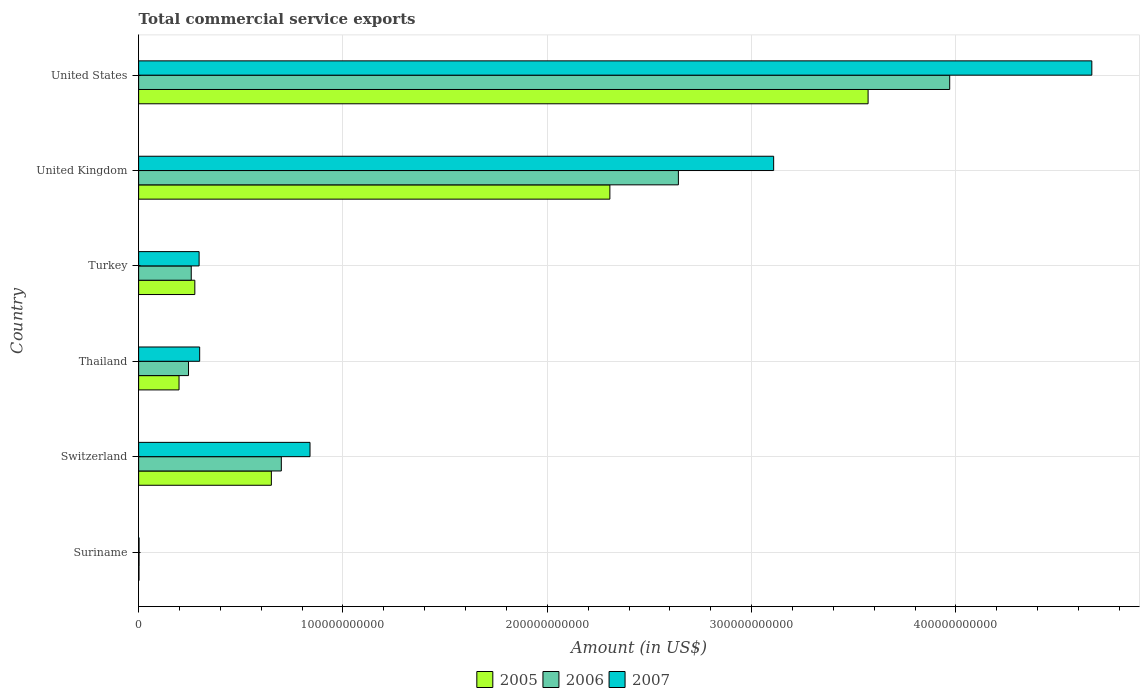How many groups of bars are there?
Keep it short and to the point. 6. Are the number of bars per tick equal to the number of legend labels?
Your answer should be compact. Yes. How many bars are there on the 1st tick from the top?
Give a very brief answer. 3. How many bars are there on the 5th tick from the bottom?
Ensure brevity in your answer.  3. What is the total commercial service exports in 2005 in United States?
Your answer should be compact. 3.57e+11. Across all countries, what is the maximum total commercial service exports in 2005?
Your answer should be very brief. 3.57e+11. Across all countries, what is the minimum total commercial service exports in 2005?
Give a very brief answer. 1.83e+08. In which country was the total commercial service exports in 2007 minimum?
Offer a terse response. Suriname. What is the total total commercial service exports in 2006 in the graph?
Make the answer very short. 7.81e+11. What is the difference between the total commercial service exports in 2006 in Suriname and that in Turkey?
Offer a very short reply. -2.55e+1. What is the difference between the total commercial service exports in 2005 in United Kingdom and the total commercial service exports in 2006 in United States?
Provide a short and direct response. -1.66e+11. What is the average total commercial service exports in 2005 per country?
Provide a succinct answer. 1.17e+11. What is the difference between the total commercial service exports in 2007 and total commercial service exports in 2005 in United Kingdom?
Keep it short and to the point. 8.02e+1. In how many countries, is the total commercial service exports in 2005 greater than 320000000000 US$?
Offer a very short reply. 1. What is the ratio of the total commercial service exports in 2006 in Switzerland to that in United Kingdom?
Your answer should be compact. 0.26. Is the total commercial service exports in 2007 in Switzerland less than that in United Kingdom?
Provide a succinct answer. Yes. What is the difference between the highest and the second highest total commercial service exports in 2007?
Keep it short and to the point. 1.56e+11. What is the difference between the highest and the lowest total commercial service exports in 2005?
Offer a very short reply. 3.57e+11. In how many countries, is the total commercial service exports in 2006 greater than the average total commercial service exports in 2006 taken over all countries?
Ensure brevity in your answer.  2. Is the sum of the total commercial service exports in 2007 in Suriname and United Kingdom greater than the maximum total commercial service exports in 2005 across all countries?
Your answer should be very brief. No. What does the 3rd bar from the bottom in United States represents?
Your answer should be compact. 2007. Is it the case that in every country, the sum of the total commercial service exports in 2007 and total commercial service exports in 2006 is greater than the total commercial service exports in 2005?
Offer a very short reply. Yes. How many bars are there?
Your answer should be compact. 18. Are all the bars in the graph horizontal?
Your answer should be very brief. Yes. What is the difference between two consecutive major ticks on the X-axis?
Offer a very short reply. 1.00e+11. Are the values on the major ticks of X-axis written in scientific E-notation?
Offer a very short reply. No. Does the graph contain any zero values?
Provide a short and direct response. No. Does the graph contain grids?
Provide a succinct answer. Yes. Where does the legend appear in the graph?
Provide a succinct answer. Bottom center. How many legend labels are there?
Provide a succinct answer. 3. How are the legend labels stacked?
Your response must be concise. Horizontal. What is the title of the graph?
Ensure brevity in your answer.  Total commercial service exports. What is the label or title of the X-axis?
Ensure brevity in your answer.  Amount (in US$). What is the label or title of the Y-axis?
Ensure brevity in your answer.  Country. What is the Amount (in US$) of 2005 in Suriname?
Provide a succinct answer. 1.83e+08. What is the Amount (in US$) of 2006 in Suriname?
Give a very brief answer. 2.14e+08. What is the Amount (in US$) of 2007 in Suriname?
Give a very brief answer. 2.19e+08. What is the Amount (in US$) of 2005 in Switzerland?
Your response must be concise. 6.50e+1. What is the Amount (in US$) of 2006 in Switzerland?
Your response must be concise. 6.98e+1. What is the Amount (in US$) of 2007 in Switzerland?
Give a very brief answer. 8.39e+1. What is the Amount (in US$) of 2005 in Thailand?
Give a very brief answer. 1.98e+1. What is the Amount (in US$) of 2006 in Thailand?
Make the answer very short. 2.44e+1. What is the Amount (in US$) in 2007 in Thailand?
Your response must be concise. 2.99e+1. What is the Amount (in US$) in 2005 in Turkey?
Keep it short and to the point. 2.75e+1. What is the Amount (in US$) of 2006 in Turkey?
Ensure brevity in your answer.  2.58e+1. What is the Amount (in US$) in 2007 in Turkey?
Provide a succinct answer. 2.96e+1. What is the Amount (in US$) in 2005 in United Kingdom?
Your response must be concise. 2.31e+11. What is the Amount (in US$) of 2006 in United Kingdom?
Provide a succinct answer. 2.64e+11. What is the Amount (in US$) of 2007 in United Kingdom?
Your answer should be very brief. 3.11e+11. What is the Amount (in US$) in 2005 in United States?
Offer a very short reply. 3.57e+11. What is the Amount (in US$) of 2006 in United States?
Provide a short and direct response. 3.97e+11. What is the Amount (in US$) of 2007 in United States?
Provide a succinct answer. 4.67e+11. Across all countries, what is the maximum Amount (in US$) of 2005?
Your answer should be very brief. 3.57e+11. Across all countries, what is the maximum Amount (in US$) in 2006?
Provide a succinct answer. 3.97e+11. Across all countries, what is the maximum Amount (in US$) of 2007?
Give a very brief answer. 4.67e+11. Across all countries, what is the minimum Amount (in US$) of 2005?
Keep it short and to the point. 1.83e+08. Across all countries, what is the minimum Amount (in US$) of 2006?
Your answer should be very brief. 2.14e+08. Across all countries, what is the minimum Amount (in US$) of 2007?
Your answer should be compact. 2.19e+08. What is the total Amount (in US$) in 2005 in the graph?
Your answer should be very brief. 7.00e+11. What is the total Amount (in US$) in 2006 in the graph?
Ensure brevity in your answer.  7.81e+11. What is the total Amount (in US$) in 2007 in the graph?
Offer a terse response. 9.21e+11. What is the difference between the Amount (in US$) of 2005 in Suriname and that in Switzerland?
Your answer should be very brief. -6.48e+1. What is the difference between the Amount (in US$) in 2006 in Suriname and that in Switzerland?
Make the answer very short. -6.96e+1. What is the difference between the Amount (in US$) in 2007 in Suriname and that in Switzerland?
Keep it short and to the point. -8.37e+1. What is the difference between the Amount (in US$) of 2005 in Suriname and that in Thailand?
Your answer should be compact. -1.96e+1. What is the difference between the Amount (in US$) in 2006 in Suriname and that in Thailand?
Your response must be concise. -2.42e+1. What is the difference between the Amount (in US$) in 2007 in Suriname and that in Thailand?
Keep it short and to the point. -2.97e+1. What is the difference between the Amount (in US$) in 2005 in Suriname and that in Turkey?
Offer a terse response. -2.73e+1. What is the difference between the Amount (in US$) of 2006 in Suriname and that in Turkey?
Offer a very short reply. -2.55e+1. What is the difference between the Amount (in US$) in 2007 in Suriname and that in Turkey?
Provide a short and direct response. -2.94e+1. What is the difference between the Amount (in US$) of 2005 in Suriname and that in United Kingdom?
Your response must be concise. -2.30e+11. What is the difference between the Amount (in US$) of 2006 in Suriname and that in United Kingdom?
Offer a terse response. -2.64e+11. What is the difference between the Amount (in US$) of 2007 in Suriname and that in United Kingdom?
Offer a terse response. -3.11e+11. What is the difference between the Amount (in US$) in 2005 in Suriname and that in United States?
Provide a short and direct response. -3.57e+11. What is the difference between the Amount (in US$) in 2006 in Suriname and that in United States?
Your answer should be very brief. -3.97e+11. What is the difference between the Amount (in US$) in 2007 in Suriname and that in United States?
Keep it short and to the point. -4.66e+11. What is the difference between the Amount (in US$) in 2005 in Switzerland and that in Thailand?
Keep it short and to the point. 4.52e+1. What is the difference between the Amount (in US$) of 2006 in Switzerland and that in Thailand?
Provide a short and direct response. 4.54e+1. What is the difference between the Amount (in US$) in 2007 in Switzerland and that in Thailand?
Your answer should be very brief. 5.40e+1. What is the difference between the Amount (in US$) in 2005 in Switzerland and that in Turkey?
Ensure brevity in your answer.  3.75e+1. What is the difference between the Amount (in US$) of 2006 in Switzerland and that in Turkey?
Keep it short and to the point. 4.41e+1. What is the difference between the Amount (in US$) in 2007 in Switzerland and that in Turkey?
Your answer should be very brief. 5.43e+1. What is the difference between the Amount (in US$) in 2005 in Switzerland and that in United Kingdom?
Keep it short and to the point. -1.66e+11. What is the difference between the Amount (in US$) in 2006 in Switzerland and that in United Kingdom?
Provide a succinct answer. -1.94e+11. What is the difference between the Amount (in US$) in 2007 in Switzerland and that in United Kingdom?
Your response must be concise. -2.27e+11. What is the difference between the Amount (in US$) of 2005 in Switzerland and that in United States?
Make the answer very short. -2.92e+11. What is the difference between the Amount (in US$) of 2006 in Switzerland and that in United States?
Your answer should be very brief. -3.27e+11. What is the difference between the Amount (in US$) of 2007 in Switzerland and that in United States?
Offer a very short reply. -3.83e+11. What is the difference between the Amount (in US$) of 2005 in Thailand and that in Turkey?
Make the answer very short. -7.73e+09. What is the difference between the Amount (in US$) of 2006 in Thailand and that in Turkey?
Offer a terse response. -1.34e+09. What is the difference between the Amount (in US$) of 2007 in Thailand and that in Turkey?
Keep it short and to the point. 2.75e+08. What is the difference between the Amount (in US$) in 2005 in Thailand and that in United Kingdom?
Offer a very short reply. -2.11e+11. What is the difference between the Amount (in US$) of 2006 in Thailand and that in United Kingdom?
Your answer should be very brief. -2.40e+11. What is the difference between the Amount (in US$) of 2007 in Thailand and that in United Kingdom?
Provide a succinct answer. -2.81e+11. What is the difference between the Amount (in US$) of 2005 in Thailand and that in United States?
Offer a very short reply. -3.37e+11. What is the difference between the Amount (in US$) of 2006 in Thailand and that in United States?
Provide a short and direct response. -3.73e+11. What is the difference between the Amount (in US$) in 2007 in Thailand and that in United States?
Offer a terse response. -4.37e+11. What is the difference between the Amount (in US$) in 2005 in Turkey and that in United Kingdom?
Keep it short and to the point. -2.03e+11. What is the difference between the Amount (in US$) of 2006 in Turkey and that in United Kingdom?
Provide a succinct answer. -2.38e+11. What is the difference between the Amount (in US$) of 2007 in Turkey and that in United Kingdom?
Make the answer very short. -2.81e+11. What is the difference between the Amount (in US$) in 2005 in Turkey and that in United States?
Your answer should be very brief. -3.30e+11. What is the difference between the Amount (in US$) of 2006 in Turkey and that in United States?
Your answer should be very brief. -3.71e+11. What is the difference between the Amount (in US$) of 2007 in Turkey and that in United States?
Give a very brief answer. -4.37e+11. What is the difference between the Amount (in US$) of 2005 in United Kingdom and that in United States?
Your answer should be compact. -1.26e+11. What is the difference between the Amount (in US$) in 2006 in United Kingdom and that in United States?
Provide a short and direct response. -1.33e+11. What is the difference between the Amount (in US$) in 2007 in United Kingdom and that in United States?
Your answer should be compact. -1.56e+11. What is the difference between the Amount (in US$) of 2005 in Suriname and the Amount (in US$) of 2006 in Switzerland?
Ensure brevity in your answer.  -6.97e+1. What is the difference between the Amount (in US$) of 2005 in Suriname and the Amount (in US$) of 2007 in Switzerland?
Keep it short and to the point. -8.37e+1. What is the difference between the Amount (in US$) of 2006 in Suriname and the Amount (in US$) of 2007 in Switzerland?
Provide a short and direct response. -8.37e+1. What is the difference between the Amount (in US$) in 2005 in Suriname and the Amount (in US$) in 2006 in Thailand?
Your answer should be very brief. -2.42e+1. What is the difference between the Amount (in US$) in 2005 in Suriname and the Amount (in US$) in 2007 in Thailand?
Your response must be concise. -2.97e+1. What is the difference between the Amount (in US$) of 2006 in Suriname and the Amount (in US$) of 2007 in Thailand?
Offer a very short reply. -2.97e+1. What is the difference between the Amount (in US$) in 2005 in Suriname and the Amount (in US$) in 2006 in Turkey?
Make the answer very short. -2.56e+1. What is the difference between the Amount (in US$) in 2005 in Suriname and the Amount (in US$) in 2007 in Turkey?
Your answer should be compact. -2.94e+1. What is the difference between the Amount (in US$) of 2006 in Suriname and the Amount (in US$) of 2007 in Turkey?
Keep it short and to the point. -2.94e+1. What is the difference between the Amount (in US$) of 2005 in Suriname and the Amount (in US$) of 2006 in United Kingdom?
Provide a short and direct response. -2.64e+11. What is the difference between the Amount (in US$) in 2005 in Suriname and the Amount (in US$) in 2007 in United Kingdom?
Make the answer very short. -3.11e+11. What is the difference between the Amount (in US$) in 2006 in Suriname and the Amount (in US$) in 2007 in United Kingdom?
Offer a terse response. -3.11e+11. What is the difference between the Amount (in US$) in 2005 in Suriname and the Amount (in US$) in 2006 in United States?
Offer a very short reply. -3.97e+11. What is the difference between the Amount (in US$) of 2005 in Suriname and the Amount (in US$) of 2007 in United States?
Ensure brevity in your answer.  -4.66e+11. What is the difference between the Amount (in US$) of 2006 in Suriname and the Amount (in US$) of 2007 in United States?
Your answer should be compact. -4.66e+11. What is the difference between the Amount (in US$) of 2005 in Switzerland and the Amount (in US$) of 2006 in Thailand?
Your answer should be compact. 4.05e+1. What is the difference between the Amount (in US$) in 2005 in Switzerland and the Amount (in US$) in 2007 in Thailand?
Provide a short and direct response. 3.51e+1. What is the difference between the Amount (in US$) in 2006 in Switzerland and the Amount (in US$) in 2007 in Thailand?
Your response must be concise. 4.00e+1. What is the difference between the Amount (in US$) in 2005 in Switzerland and the Amount (in US$) in 2006 in Turkey?
Offer a very short reply. 3.92e+1. What is the difference between the Amount (in US$) in 2005 in Switzerland and the Amount (in US$) in 2007 in Turkey?
Provide a short and direct response. 3.54e+1. What is the difference between the Amount (in US$) of 2006 in Switzerland and the Amount (in US$) of 2007 in Turkey?
Provide a succinct answer. 4.02e+1. What is the difference between the Amount (in US$) in 2005 in Switzerland and the Amount (in US$) in 2006 in United Kingdom?
Offer a terse response. -1.99e+11. What is the difference between the Amount (in US$) of 2005 in Switzerland and the Amount (in US$) of 2007 in United Kingdom?
Make the answer very short. -2.46e+11. What is the difference between the Amount (in US$) of 2006 in Switzerland and the Amount (in US$) of 2007 in United Kingdom?
Give a very brief answer. -2.41e+11. What is the difference between the Amount (in US$) of 2005 in Switzerland and the Amount (in US$) of 2006 in United States?
Provide a succinct answer. -3.32e+11. What is the difference between the Amount (in US$) in 2005 in Switzerland and the Amount (in US$) in 2007 in United States?
Provide a succinct answer. -4.02e+11. What is the difference between the Amount (in US$) in 2006 in Switzerland and the Amount (in US$) in 2007 in United States?
Offer a terse response. -3.97e+11. What is the difference between the Amount (in US$) in 2005 in Thailand and the Amount (in US$) in 2006 in Turkey?
Provide a succinct answer. -5.99e+09. What is the difference between the Amount (in US$) in 2005 in Thailand and the Amount (in US$) in 2007 in Turkey?
Offer a very short reply. -9.83e+09. What is the difference between the Amount (in US$) in 2006 in Thailand and the Amount (in US$) in 2007 in Turkey?
Your answer should be very brief. -5.19e+09. What is the difference between the Amount (in US$) of 2005 in Thailand and the Amount (in US$) of 2006 in United Kingdom?
Your response must be concise. -2.44e+11. What is the difference between the Amount (in US$) in 2005 in Thailand and the Amount (in US$) in 2007 in United Kingdom?
Ensure brevity in your answer.  -2.91e+11. What is the difference between the Amount (in US$) in 2006 in Thailand and the Amount (in US$) in 2007 in United Kingdom?
Your answer should be compact. -2.86e+11. What is the difference between the Amount (in US$) in 2005 in Thailand and the Amount (in US$) in 2006 in United States?
Provide a short and direct response. -3.77e+11. What is the difference between the Amount (in US$) of 2005 in Thailand and the Amount (in US$) of 2007 in United States?
Your answer should be compact. -4.47e+11. What is the difference between the Amount (in US$) of 2006 in Thailand and the Amount (in US$) of 2007 in United States?
Your answer should be very brief. -4.42e+11. What is the difference between the Amount (in US$) of 2005 in Turkey and the Amount (in US$) of 2006 in United Kingdom?
Provide a succinct answer. -2.37e+11. What is the difference between the Amount (in US$) in 2005 in Turkey and the Amount (in US$) in 2007 in United Kingdom?
Keep it short and to the point. -2.83e+11. What is the difference between the Amount (in US$) of 2006 in Turkey and the Amount (in US$) of 2007 in United Kingdom?
Offer a very short reply. -2.85e+11. What is the difference between the Amount (in US$) of 2005 in Turkey and the Amount (in US$) of 2006 in United States?
Keep it short and to the point. -3.69e+11. What is the difference between the Amount (in US$) in 2005 in Turkey and the Amount (in US$) in 2007 in United States?
Give a very brief answer. -4.39e+11. What is the difference between the Amount (in US$) of 2006 in Turkey and the Amount (in US$) of 2007 in United States?
Keep it short and to the point. -4.41e+11. What is the difference between the Amount (in US$) in 2005 in United Kingdom and the Amount (in US$) in 2006 in United States?
Your answer should be compact. -1.66e+11. What is the difference between the Amount (in US$) in 2005 in United Kingdom and the Amount (in US$) in 2007 in United States?
Ensure brevity in your answer.  -2.36e+11. What is the difference between the Amount (in US$) in 2006 in United Kingdom and the Amount (in US$) in 2007 in United States?
Your answer should be compact. -2.02e+11. What is the average Amount (in US$) in 2005 per country?
Provide a short and direct response. 1.17e+11. What is the average Amount (in US$) of 2006 per country?
Ensure brevity in your answer.  1.30e+11. What is the average Amount (in US$) of 2007 per country?
Offer a very short reply. 1.53e+11. What is the difference between the Amount (in US$) of 2005 and Amount (in US$) of 2006 in Suriname?
Provide a short and direct response. -3.10e+07. What is the difference between the Amount (in US$) of 2005 and Amount (in US$) of 2007 in Suriname?
Offer a terse response. -3.61e+07. What is the difference between the Amount (in US$) in 2006 and Amount (in US$) in 2007 in Suriname?
Offer a terse response. -5.10e+06. What is the difference between the Amount (in US$) of 2005 and Amount (in US$) of 2006 in Switzerland?
Provide a succinct answer. -4.88e+09. What is the difference between the Amount (in US$) in 2005 and Amount (in US$) in 2007 in Switzerland?
Your response must be concise. -1.89e+1. What is the difference between the Amount (in US$) of 2006 and Amount (in US$) of 2007 in Switzerland?
Provide a short and direct response. -1.40e+1. What is the difference between the Amount (in US$) of 2005 and Amount (in US$) of 2006 in Thailand?
Provide a short and direct response. -4.64e+09. What is the difference between the Amount (in US$) of 2005 and Amount (in US$) of 2007 in Thailand?
Provide a short and direct response. -1.01e+1. What is the difference between the Amount (in US$) in 2006 and Amount (in US$) in 2007 in Thailand?
Provide a short and direct response. -5.46e+09. What is the difference between the Amount (in US$) of 2005 and Amount (in US$) of 2006 in Turkey?
Offer a terse response. 1.75e+09. What is the difference between the Amount (in US$) of 2005 and Amount (in US$) of 2007 in Turkey?
Offer a terse response. -2.10e+09. What is the difference between the Amount (in US$) of 2006 and Amount (in US$) of 2007 in Turkey?
Offer a very short reply. -3.84e+09. What is the difference between the Amount (in US$) of 2005 and Amount (in US$) of 2006 in United Kingdom?
Provide a short and direct response. -3.35e+1. What is the difference between the Amount (in US$) of 2005 and Amount (in US$) of 2007 in United Kingdom?
Ensure brevity in your answer.  -8.02e+1. What is the difference between the Amount (in US$) of 2006 and Amount (in US$) of 2007 in United Kingdom?
Ensure brevity in your answer.  -4.66e+1. What is the difference between the Amount (in US$) in 2005 and Amount (in US$) in 2006 in United States?
Your response must be concise. -3.99e+1. What is the difference between the Amount (in US$) of 2005 and Amount (in US$) of 2007 in United States?
Offer a terse response. -1.09e+11. What is the difference between the Amount (in US$) of 2006 and Amount (in US$) of 2007 in United States?
Ensure brevity in your answer.  -6.96e+1. What is the ratio of the Amount (in US$) in 2005 in Suriname to that in Switzerland?
Keep it short and to the point. 0. What is the ratio of the Amount (in US$) of 2006 in Suriname to that in Switzerland?
Make the answer very short. 0. What is the ratio of the Amount (in US$) in 2007 in Suriname to that in Switzerland?
Your answer should be compact. 0. What is the ratio of the Amount (in US$) in 2005 in Suriname to that in Thailand?
Your response must be concise. 0.01. What is the ratio of the Amount (in US$) in 2006 in Suriname to that in Thailand?
Give a very brief answer. 0.01. What is the ratio of the Amount (in US$) of 2007 in Suriname to that in Thailand?
Provide a succinct answer. 0.01. What is the ratio of the Amount (in US$) of 2005 in Suriname to that in Turkey?
Your response must be concise. 0.01. What is the ratio of the Amount (in US$) of 2006 in Suriname to that in Turkey?
Ensure brevity in your answer.  0.01. What is the ratio of the Amount (in US$) in 2007 in Suriname to that in Turkey?
Make the answer very short. 0.01. What is the ratio of the Amount (in US$) in 2005 in Suriname to that in United Kingdom?
Your answer should be very brief. 0. What is the ratio of the Amount (in US$) in 2006 in Suriname to that in United Kingdom?
Make the answer very short. 0. What is the ratio of the Amount (in US$) in 2007 in Suriname to that in United Kingdom?
Your answer should be very brief. 0. What is the ratio of the Amount (in US$) in 2005 in Switzerland to that in Thailand?
Offer a terse response. 3.29. What is the ratio of the Amount (in US$) in 2006 in Switzerland to that in Thailand?
Offer a terse response. 2.86. What is the ratio of the Amount (in US$) in 2007 in Switzerland to that in Thailand?
Your response must be concise. 2.81. What is the ratio of the Amount (in US$) in 2005 in Switzerland to that in Turkey?
Your answer should be very brief. 2.36. What is the ratio of the Amount (in US$) in 2006 in Switzerland to that in Turkey?
Offer a very short reply. 2.71. What is the ratio of the Amount (in US$) of 2007 in Switzerland to that in Turkey?
Your answer should be compact. 2.83. What is the ratio of the Amount (in US$) in 2005 in Switzerland to that in United Kingdom?
Keep it short and to the point. 0.28. What is the ratio of the Amount (in US$) of 2006 in Switzerland to that in United Kingdom?
Offer a very short reply. 0.26. What is the ratio of the Amount (in US$) in 2007 in Switzerland to that in United Kingdom?
Give a very brief answer. 0.27. What is the ratio of the Amount (in US$) in 2005 in Switzerland to that in United States?
Provide a short and direct response. 0.18. What is the ratio of the Amount (in US$) in 2006 in Switzerland to that in United States?
Ensure brevity in your answer.  0.18. What is the ratio of the Amount (in US$) of 2007 in Switzerland to that in United States?
Provide a short and direct response. 0.18. What is the ratio of the Amount (in US$) of 2005 in Thailand to that in Turkey?
Offer a terse response. 0.72. What is the ratio of the Amount (in US$) of 2006 in Thailand to that in Turkey?
Ensure brevity in your answer.  0.95. What is the ratio of the Amount (in US$) of 2007 in Thailand to that in Turkey?
Ensure brevity in your answer.  1.01. What is the ratio of the Amount (in US$) of 2005 in Thailand to that in United Kingdom?
Offer a terse response. 0.09. What is the ratio of the Amount (in US$) in 2006 in Thailand to that in United Kingdom?
Ensure brevity in your answer.  0.09. What is the ratio of the Amount (in US$) of 2007 in Thailand to that in United Kingdom?
Offer a very short reply. 0.1. What is the ratio of the Amount (in US$) of 2005 in Thailand to that in United States?
Your answer should be very brief. 0.06. What is the ratio of the Amount (in US$) in 2006 in Thailand to that in United States?
Your answer should be very brief. 0.06. What is the ratio of the Amount (in US$) in 2007 in Thailand to that in United States?
Ensure brevity in your answer.  0.06. What is the ratio of the Amount (in US$) in 2005 in Turkey to that in United Kingdom?
Ensure brevity in your answer.  0.12. What is the ratio of the Amount (in US$) of 2006 in Turkey to that in United Kingdom?
Provide a short and direct response. 0.1. What is the ratio of the Amount (in US$) of 2007 in Turkey to that in United Kingdom?
Provide a succinct answer. 0.1. What is the ratio of the Amount (in US$) of 2005 in Turkey to that in United States?
Offer a very short reply. 0.08. What is the ratio of the Amount (in US$) in 2006 in Turkey to that in United States?
Make the answer very short. 0.06. What is the ratio of the Amount (in US$) of 2007 in Turkey to that in United States?
Give a very brief answer. 0.06. What is the ratio of the Amount (in US$) in 2005 in United Kingdom to that in United States?
Provide a succinct answer. 0.65. What is the ratio of the Amount (in US$) in 2006 in United Kingdom to that in United States?
Offer a terse response. 0.67. What is the ratio of the Amount (in US$) of 2007 in United Kingdom to that in United States?
Offer a terse response. 0.67. What is the difference between the highest and the second highest Amount (in US$) of 2005?
Offer a very short reply. 1.26e+11. What is the difference between the highest and the second highest Amount (in US$) in 2006?
Provide a short and direct response. 1.33e+11. What is the difference between the highest and the second highest Amount (in US$) in 2007?
Give a very brief answer. 1.56e+11. What is the difference between the highest and the lowest Amount (in US$) of 2005?
Keep it short and to the point. 3.57e+11. What is the difference between the highest and the lowest Amount (in US$) of 2006?
Offer a very short reply. 3.97e+11. What is the difference between the highest and the lowest Amount (in US$) in 2007?
Offer a very short reply. 4.66e+11. 